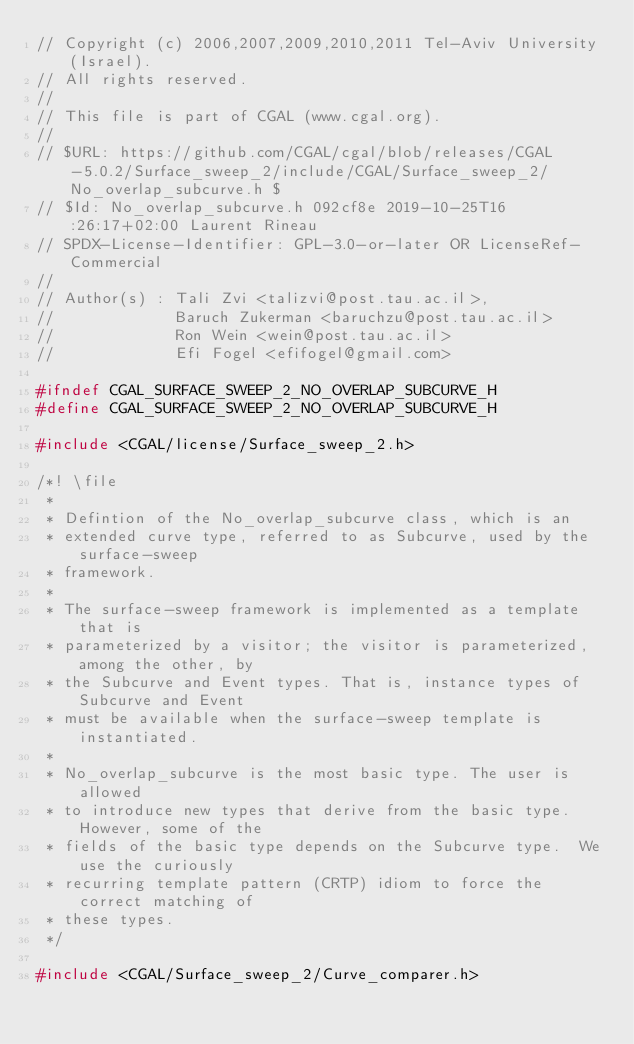<code> <loc_0><loc_0><loc_500><loc_500><_C_>// Copyright (c) 2006,2007,2009,2010,2011 Tel-Aviv University (Israel).
// All rights reserved.
//
// This file is part of CGAL (www.cgal.org).
//
// $URL: https://github.com/CGAL/cgal/blob/releases/CGAL-5.0.2/Surface_sweep_2/include/CGAL/Surface_sweep_2/No_overlap_subcurve.h $
// $Id: No_overlap_subcurve.h 092cf8e 2019-10-25T16:26:17+02:00 Laurent Rineau
// SPDX-License-Identifier: GPL-3.0-or-later OR LicenseRef-Commercial
//
// Author(s) : Tali Zvi <talizvi@post.tau.ac.il>,
//             Baruch Zukerman <baruchzu@post.tau.ac.il>
//             Ron Wein <wein@post.tau.ac.il>
//             Efi Fogel <efifogel@gmail.com>

#ifndef CGAL_SURFACE_SWEEP_2_NO_OVERLAP_SUBCURVE_H
#define CGAL_SURFACE_SWEEP_2_NO_OVERLAP_SUBCURVE_H

#include <CGAL/license/Surface_sweep_2.h>

/*! \file
 *
 * Defintion of the No_overlap_subcurve class, which is an
 * extended curve type, referred to as Subcurve, used by the surface-sweep
 * framework.
 *
 * The surface-sweep framework is implemented as a template that is
 * parameterized by a visitor; the visitor is parameterized, among the other, by
 * the Subcurve and Event types. That is, instance types of Subcurve and Event
 * must be available when the surface-sweep template is instantiated.
 *
 * No_overlap_subcurve is the most basic type. The user is allowed
 * to introduce new types that derive from the basic type. However, some of the
 * fields of the basic type depends on the Subcurve type.  We use the curiously
 * recurring template pattern (CRTP) idiom to force the correct matching of
 * these types.
 */

#include <CGAL/Surface_sweep_2/Curve_comparer.h></code> 